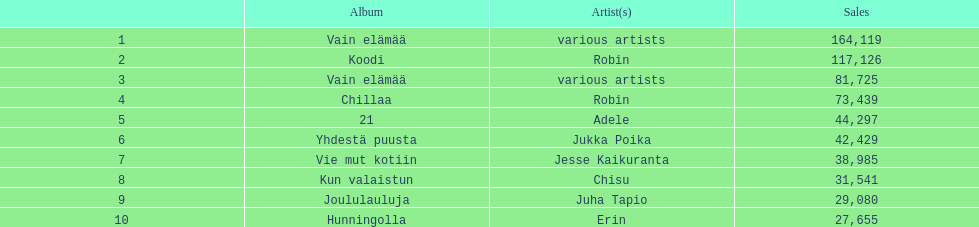Which album has the highest number of sales but doesn't have a designated artist? Vain elämää. 